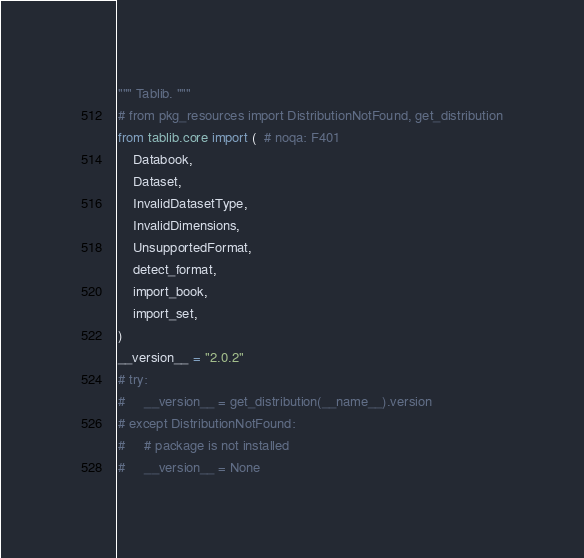Convert code to text. <code><loc_0><loc_0><loc_500><loc_500><_Python_>""" Tablib. """
# from pkg_resources import DistributionNotFound, get_distribution
from tablib.core import (  # noqa: F401
    Databook,
    Dataset,
    InvalidDatasetType,
    InvalidDimensions,
    UnsupportedFormat,
    detect_format,
    import_book,
    import_set,
)
__version__ = "2.0.2"
# try:
#     __version__ = get_distribution(__name__).version
# except DistributionNotFound:
#     # package is not installed
#     __version__ = None
</code> 